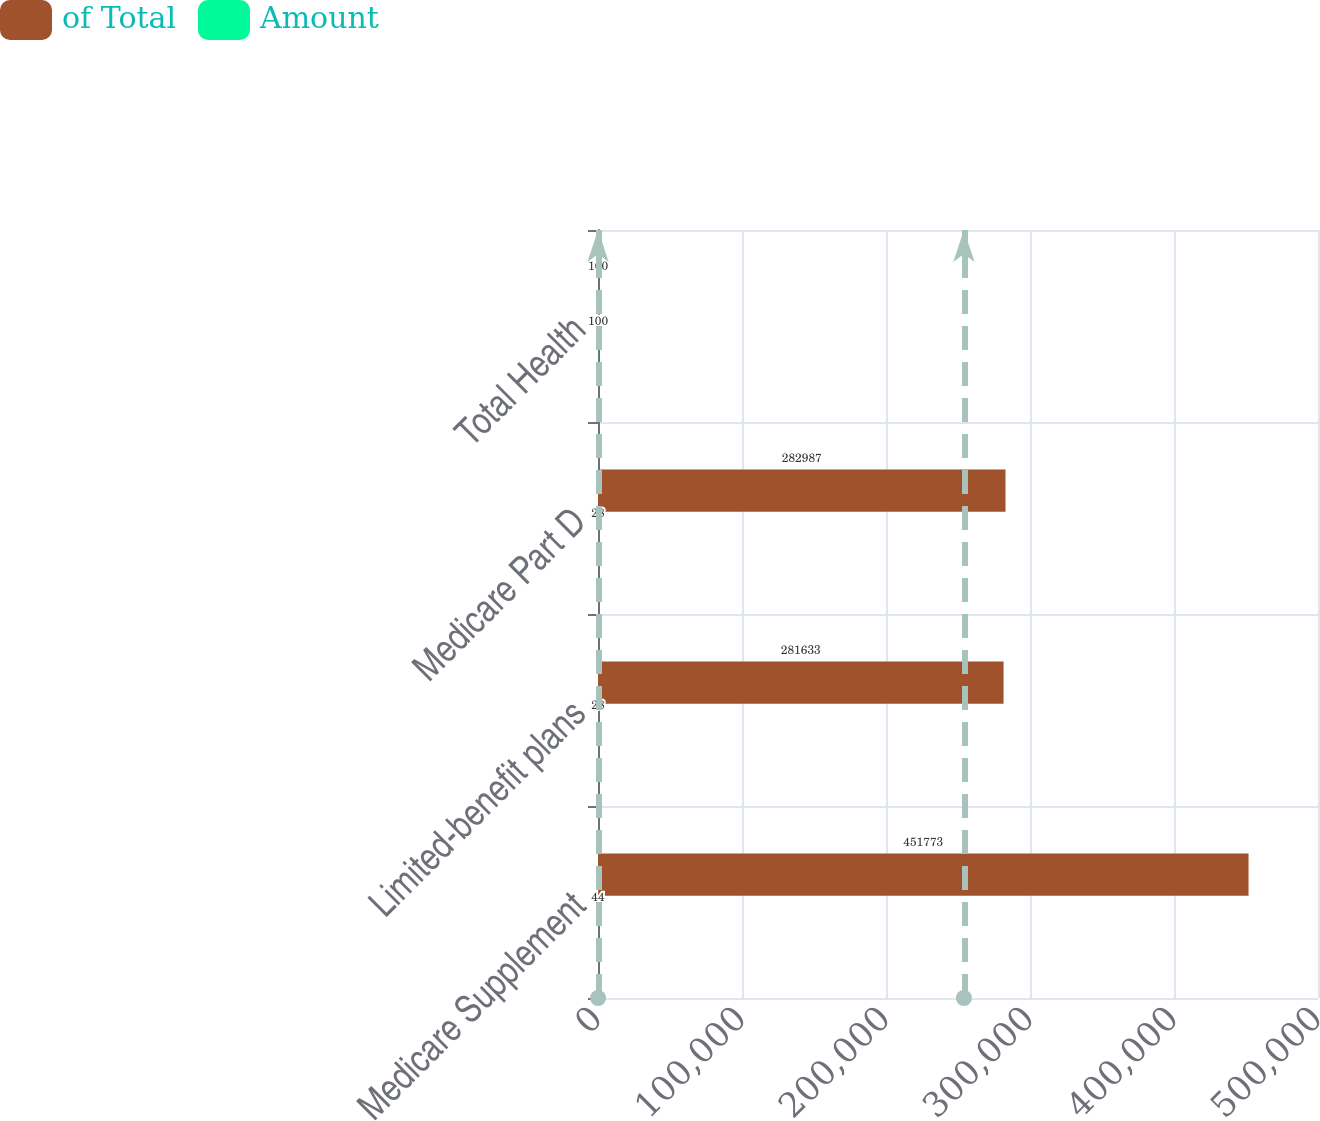Convert chart to OTSL. <chart><loc_0><loc_0><loc_500><loc_500><stacked_bar_chart><ecel><fcel>Medicare Supplement<fcel>Limited-benefit plans<fcel>Medicare Part D<fcel>Total Health<nl><fcel>of Total<fcel>451773<fcel>281633<fcel>282987<fcel>100<nl><fcel>Amount<fcel>44<fcel>28<fcel>28<fcel>100<nl></chart> 